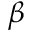<formula> <loc_0><loc_0><loc_500><loc_500>\beta</formula> 